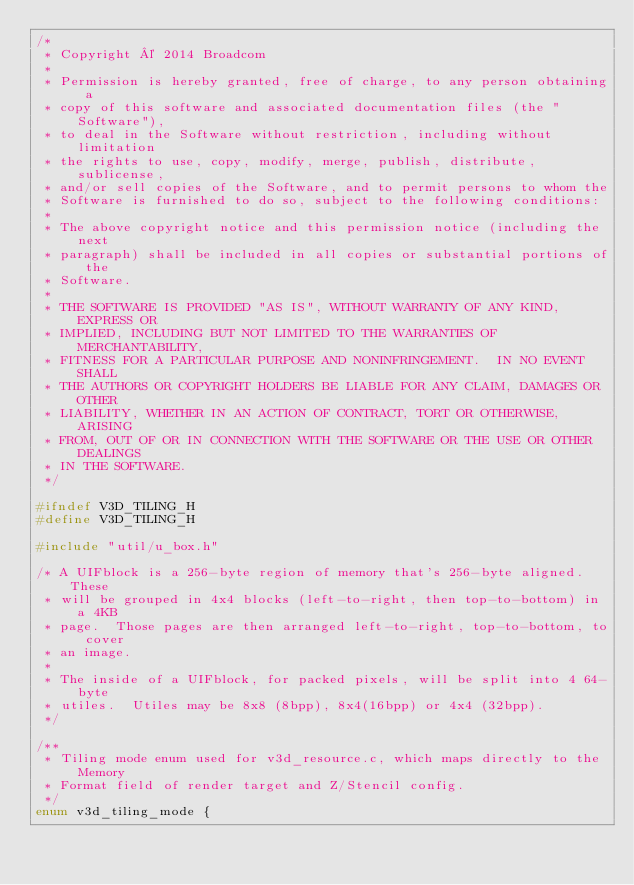<code> <loc_0><loc_0><loc_500><loc_500><_C_>/*
 * Copyright © 2014 Broadcom
 *
 * Permission is hereby granted, free of charge, to any person obtaining a
 * copy of this software and associated documentation files (the "Software"),
 * to deal in the Software without restriction, including without limitation
 * the rights to use, copy, modify, merge, publish, distribute, sublicense,
 * and/or sell copies of the Software, and to permit persons to whom the
 * Software is furnished to do so, subject to the following conditions:
 *
 * The above copyright notice and this permission notice (including the next
 * paragraph) shall be included in all copies or substantial portions of the
 * Software.
 *
 * THE SOFTWARE IS PROVIDED "AS IS", WITHOUT WARRANTY OF ANY KIND, EXPRESS OR
 * IMPLIED, INCLUDING BUT NOT LIMITED TO THE WARRANTIES OF MERCHANTABILITY,
 * FITNESS FOR A PARTICULAR PURPOSE AND NONINFRINGEMENT.  IN NO EVENT SHALL
 * THE AUTHORS OR COPYRIGHT HOLDERS BE LIABLE FOR ANY CLAIM, DAMAGES OR OTHER
 * LIABILITY, WHETHER IN AN ACTION OF CONTRACT, TORT OR OTHERWISE, ARISING
 * FROM, OUT OF OR IN CONNECTION WITH THE SOFTWARE OR THE USE OR OTHER DEALINGS
 * IN THE SOFTWARE.
 */

#ifndef V3D_TILING_H
#define V3D_TILING_H

#include "util/u_box.h"

/* A UIFblock is a 256-byte region of memory that's 256-byte aligned.  These
 * will be grouped in 4x4 blocks (left-to-right, then top-to-bottom) in a 4KB
 * page.  Those pages are then arranged left-to-right, top-to-bottom, to cover
 * an image.
 *
 * The inside of a UIFblock, for packed pixels, will be split into 4 64-byte
 * utiles.  Utiles may be 8x8 (8bpp), 8x4(16bpp) or 4x4 (32bpp).
 */

/**
 * Tiling mode enum used for v3d_resource.c, which maps directly to the Memory
 * Format field of render target and Z/Stencil config.
 */
enum v3d_tiling_mode {</code> 